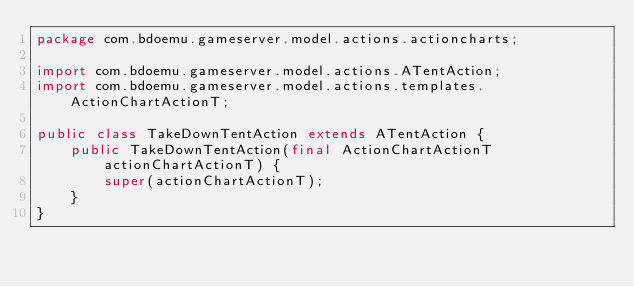<code> <loc_0><loc_0><loc_500><loc_500><_Java_>package com.bdoemu.gameserver.model.actions.actioncharts;

import com.bdoemu.gameserver.model.actions.ATentAction;
import com.bdoemu.gameserver.model.actions.templates.ActionChartActionT;

public class TakeDownTentAction extends ATentAction {
    public TakeDownTentAction(final ActionChartActionT actionChartActionT) {
        super(actionChartActionT);
    }
}
</code> 